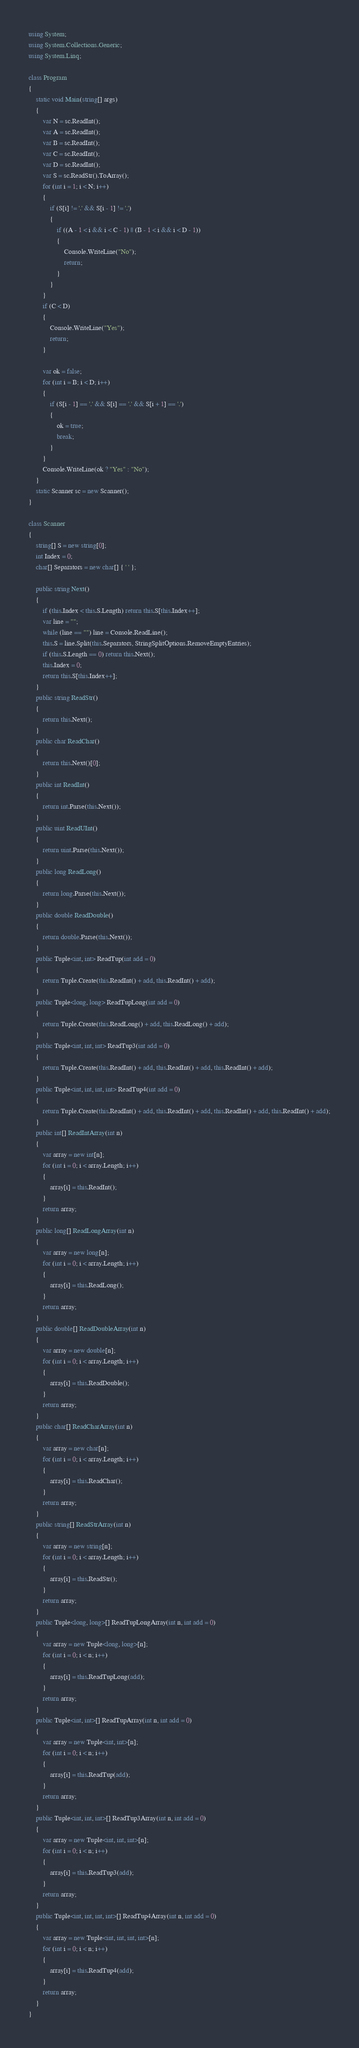Convert code to text. <code><loc_0><loc_0><loc_500><loc_500><_C#_>using System;
using System.Collections.Generic;
using System.Linq;

class Program
{
    static void Main(string[] args)
    {
        var N = sc.ReadInt();
        var A = sc.ReadInt();
        var B = sc.ReadInt();
        var C = sc.ReadInt();
        var D = sc.ReadInt();
        var S = sc.ReadStr().ToArray();
        for (int i = 1; i < N; i++)
        {
            if (S[i] != '.' && S[i - 1] != '.')
            {
                if ((A - 1 < i && i < C - 1) || (B - 1 < i && i < D - 1))
                {
                    Console.WriteLine("No");
                    return;
                }
            }
        }
        if (C < D)
        {
            Console.WriteLine("Yes");
            return;
        }

        var ok = false;
        for (int i = B; i < D; i++)
        {
            if (S[i - 1] == '.' && S[i] == '.' && S[i + 1] == '.')
            {
                ok = true;
                break;
            }
        }
        Console.WriteLine(ok ? "Yes" : "No");
    }
    static Scanner sc = new Scanner();
}

class Scanner
{
    string[] S = new string[0];
    int Index = 0;
    char[] Separators = new char[] { ' ' };

    public string Next()
    {
        if (this.Index < this.S.Length) return this.S[this.Index++];
        var line = "";
        while (line == "") line = Console.ReadLine();
        this.S = line.Split(this.Separators, StringSplitOptions.RemoveEmptyEntries);
        if (this.S.Length == 0) return this.Next();
        this.Index = 0;
        return this.S[this.Index++];
    }
    public string ReadStr()
    {
        return this.Next();
    }
    public char ReadChar()
    {
        return this.Next()[0];
    }
    public int ReadInt()
    {
        return int.Parse(this.Next());
    }
    public uint ReadUInt()
    {
        return uint.Parse(this.Next());
    }
    public long ReadLong()
    {
        return long.Parse(this.Next());
    }
    public double ReadDouble()
    {
        return double.Parse(this.Next());
    }
    public Tuple<int, int> ReadTup(int add = 0)
    {
        return Tuple.Create(this.ReadInt() + add, this.ReadInt() + add);
    }
    public Tuple<long, long> ReadTupLong(int add = 0)
    {
        return Tuple.Create(this.ReadLong() + add, this.ReadLong() + add);
    }
    public Tuple<int, int, int> ReadTup3(int add = 0)
    {
        return Tuple.Create(this.ReadInt() + add, this.ReadInt() + add, this.ReadInt() + add);
    }
    public Tuple<int, int, int, int> ReadTup4(int add = 0)
    {
        return Tuple.Create(this.ReadInt() + add, this.ReadInt() + add, this.ReadInt() + add, this.ReadInt() + add);
    }
    public int[] ReadIntArray(int n)
    {
        var array = new int[n];
        for (int i = 0; i < array.Length; i++)
        {
            array[i] = this.ReadInt();
        }
        return array;
    }
    public long[] ReadLongArray(int n)
    {
        var array = new long[n];
        for (int i = 0; i < array.Length; i++)
        {
            array[i] = this.ReadLong();
        }
        return array;
    }
    public double[] ReadDoubleArray(int n)
    {
        var array = new double[n];
        for (int i = 0; i < array.Length; i++)
        {
            array[i] = this.ReadDouble();
        }
        return array;
    }
    public char[] ReadCharArray(int n)
    {
        var array = new char[n];
        for (int i = 0; i < array.Length; i++)
        {
            array[i] = this.ReadChar();
        }
        return array;
    }
    public string[] ReadStrArray(int n)
    {
        var array = new string[n];
        for (int i = 0; i < array.Length; i++)
        {
            array[i] = this.ReadStr();
        }
        return array;
    }
    public Tuple<long, long>[] ReadTupLongArray(int n, int add = 0)
    {
        var array = new Tuple<long, long>[n];
        for (int i = 0; i < n; i++)
        {
            array[i] = this.ReadTupLong(add);
        }
        return array;
    }
    public Tuple<int, int>[] ReadTupArray(int n, int add = 0)
    {
        var array = new Tuple<int, int>[n];
        for (int i = 0; i < n; i++)
        {
            array[i] = this.ReadTup(add);
        }
        return array;
    }
    public Tuple<int, int, int>[] ReadTup3Array(int n, int add = 0)
    {
        var array = new Tuple<int, int, int>[n];
        for (int i = 0; i < n; i++)
        {
            array[i] = this.ReadTup3(add);
        }
        return array;
    }
    public Tuple<int, int, int, int>[] ReadTup4Array(int n, int add = 0)
    {
        var array = new Tuple<int, int, int, int>[n];
        for (int i = 0; i < n; i++)
        {
            array[i] = this.ReadTup4(add);
        }
        return array;
    }
}
</code> 